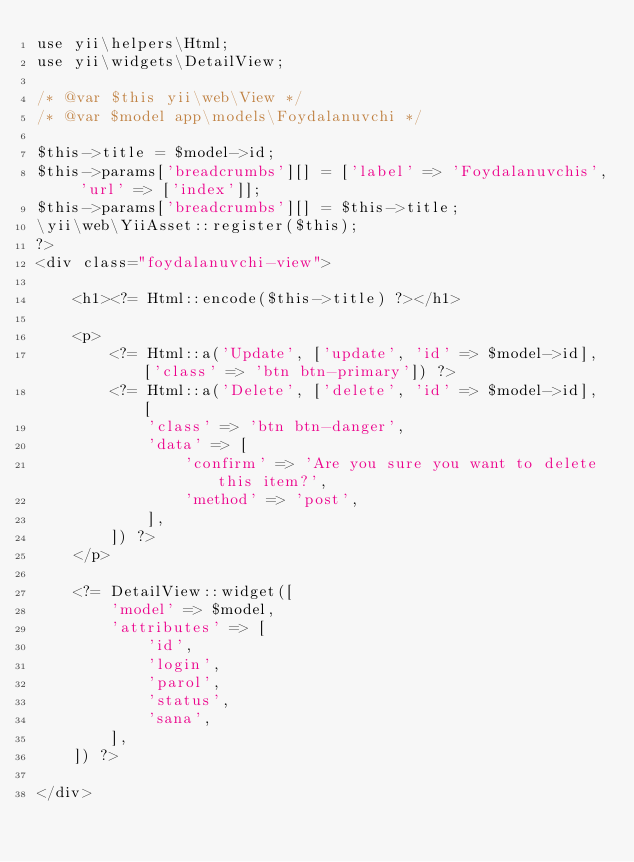Convert code to text. <code><loc_0><loc_0><loc_500><loc_500><_PHP_>use yii\helpers\Html;
use yii\widgets\DetailView;

/* @var $this yii\web\View */
/* @var $model app\models\Foydalanuvchi */

$this->title = $model->id;
$this->params['breadcrumbs'][] = ['label' => 'Foydalanuvchis', 'url' => ['index']];
$this->params['breadcrumbs'][] = $this->title;
\yii\web\YiiAsset::register($this);
?>
<div class="foydalanuvchi-view">

    <h1><?= Html::encode($this->title) ?></h1>

    <p>
        <?= Html::a('Update', ['update', 'id' => $model->id], ['class' => 'btn btn-primary']) ?>
        <?= Html::a('Delete', ['delete', 'id' => $model->id], [
            'class' => 'btn btn-danger',
            'data' => [
                'confirm' => 'Are you sure you want to delete this item?',
                'method' => 'post',
            ],
        ]) ?>
    </p>

    <?= DetailView::widget([
        'model' => $model,
        'attributes' => [
            'id',
            'login',
            'parol',
            'status',
            'sana',
        ],
    ]) ?>

</div>
</code> 